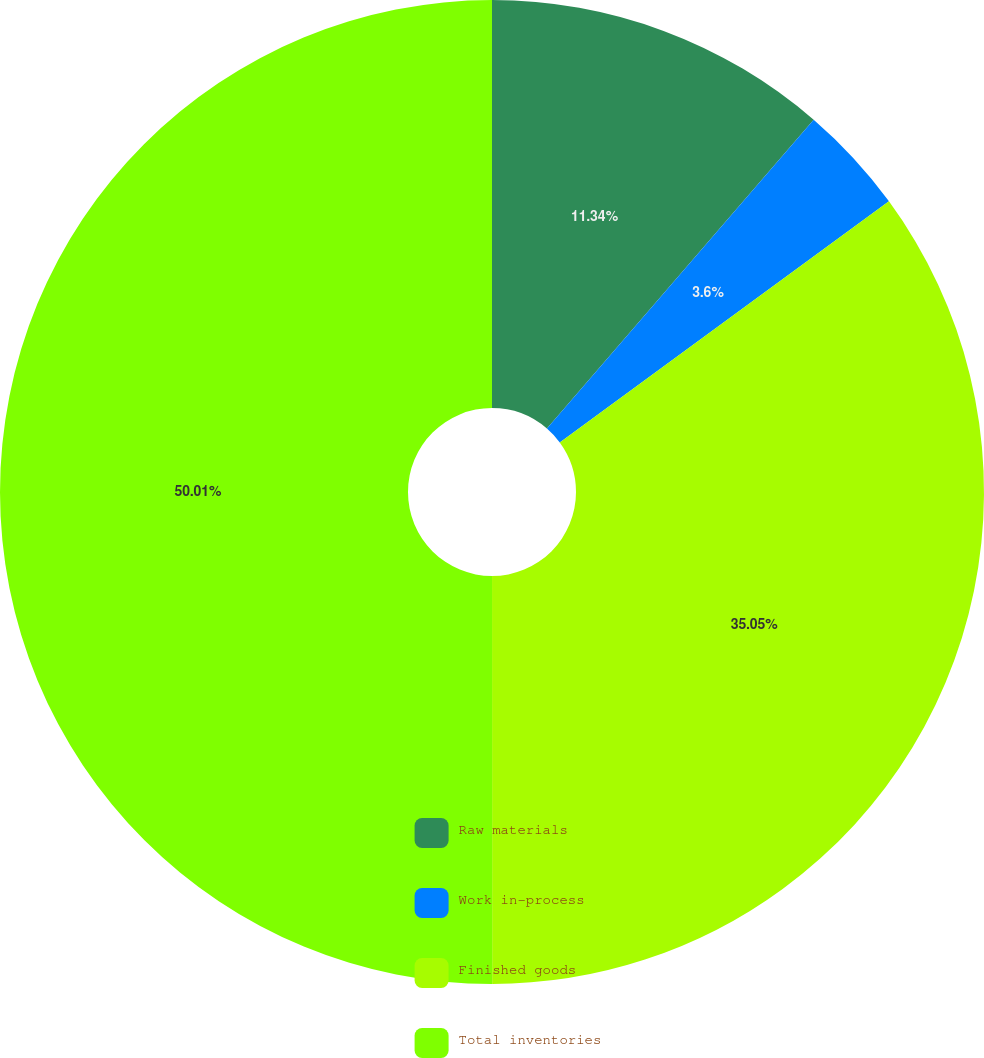Convert chart. <chart><loc_0><loc_0><loc_500><loc_500><pie_chart><fcel>Raw materials<fcel>Work in-process<fcel>Finished goods<fcel>Total inventories<nl><fcel>11.34%<fcel>3.6%<fcel>35.05%<fcel>50.0%<nl></chart> 